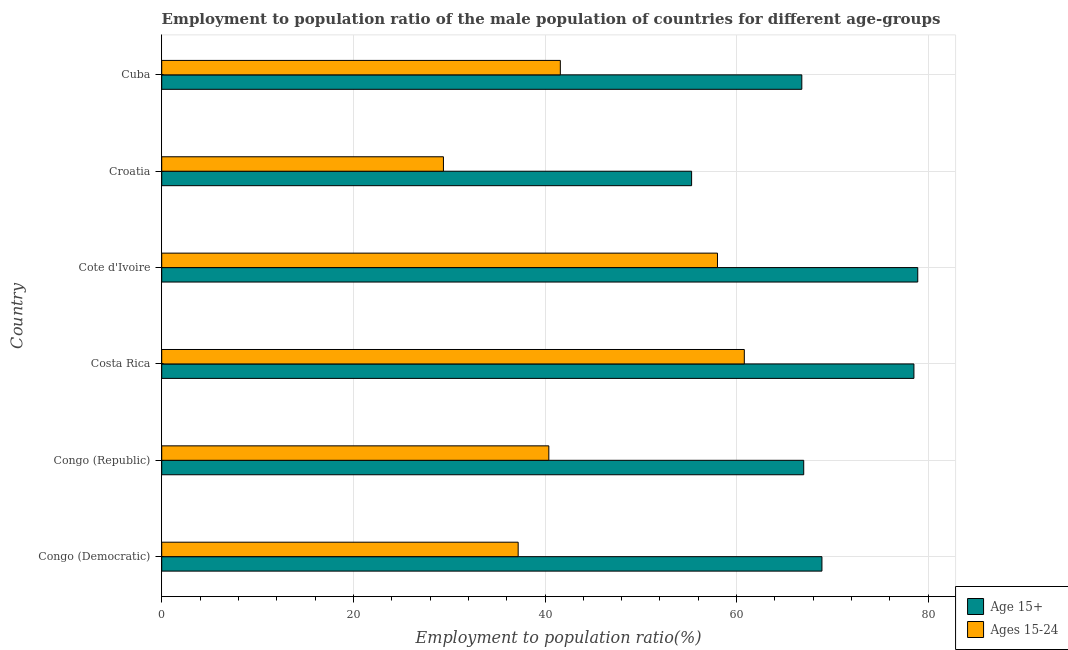How many groups of bars are there?
Give a very brief answer. 6. How many bars are there on the 4th tick from the top?
Provide a short and direct response. 2. What is the label of the 1st group of bars from the top?
Your answer should be compact. Cuba. In how many cases, is the number of bars for a given country not equal to the number of legend labels?
Provide a short and direct response. 0. What is the employment to population ratio(age 15+) in Cuba?
Offer a terse response. 66.8. Across all countries, what is the maximum employment to population ratio(age 15-24)?
Your answer should be very brief. 60.8. Across all countries, what is the minimum employment to population ratio(age 15-24)?
Offer a very short reply. 29.4. In which country was the employment to population ratio(age 15+) minimum?
Ensure brevity in your answer.  Croatia. What is the total employment to population ratio(age 15+) in the graph?
Your response must be concise. 415.4. What is the difference between the employment to population ratio(age 15-24) in Congo (Republic) and that in Cote d'Ivoire?
Offer a terse response. -17.6. What is the difference between the employment to population ratio(age 15+) in Cote d'Ivoire and the employment to population ratio(age 15-24) in Congo (Republic)?
Offer a very short reply. 38.5. What is the average employment to population ratio(age 15+) per country?
Give a very brief answer. 69.23. What is the difference between the employment to population ratio(age 15-24) and employment to population ratio(age 15+) in Costa Rica?
Provide a succinct answer. -17.7. What is the ratio of the employment to population ratio(age 15-24) in Congo (Republic) to that in Croatia?
Offer a very short reply. 1.37. What is the difference between the highest and the lowest employment to population ratio(age 15+)?
Your answer should be compact. 23.6. In how many countries, is the employment to population ratio(age 15+) greater than the average employment to population ratio(age 15+) taken over all countries?
Make the answer very short. 2. What does the 1st bar from the top in Congo (Republic) represents?
Your answer should be compact. Ages 15-24. What does the 2nd bar from the bottom in Cuba represents?
Keep it short and to the point. Ages 15-24. How many bars are there?
Make the answer very short. 12. Are all the bars in the graph horizontal?
Your answer should be compact. Yes. Does the graph contain grids?
Offer a very short reply. Yes. Where does the legend appear in the graph?
Make the answer very short. Bottom right. How are the legend labels stacked?
Provide a succinct answer. Vertical. What is the title of the graph?
Provide a succinct answer. Employment to population ratio of the male population of countries for different age-groups. Does "Under-5(female)" appear as one of the legend labels in the graph?
Make the answer very short. No. What is the label or title of the X-axis?
Your answer should be very brief. Employment to population ratio(%). What is the label or title of the Y-axis?
Ensure brevity in your answer.  Country. What is the Employment to population ratio(%) of Age 15+ in Congo (Democratic)?
Offer a terse response. 68.9. What is the Employment to population ratio(%) in Ages 15-24 in Congo (Democratic)?
Ensure brevity in your answer.  37.2. What is the Employment to population ratio(%) in Age 15+ in Congo (Republic)?
Your answer should be compact. 67. What is the Employment to population ratio(%) in Ages 15-24 in Congo (Republic)?
Provide a short and direct response. 40.4. What is the Employment to population ratio(%) of Age 15+ in Costa Rica?
Make the answer very short. 78.5. What is the Employment to population ratio(%) of Ages 15-24 in Costa Rica?
Provide a succinct answer. 60.8. What is the Employment to population ratio(%) in Age 15+ in Cote d'Ivoire?
Your response must be concise. 78.9. What is the Employment to population ratio(%) of Age 15+ in Croatia?
Your answer should be compact. 55.3. What is the Employment to population ratio(%) of Ages 15-24 in Croatia?
Give a very brief answer. 29.4. What is the Employment to population ratio(%) of Age 15+ in Cuba?
Provide a succinct answer. 66.8. What is the Employment to population ratio(%) in Ages 15-24 in Cuba?
Give a very brief answer. 41.6. Across all countries, what is the maximum Employment to population ratio(%) in Age 15+?
Provide a succinct answer. 78.9. Across all countries, what is the maximum Employment to population ratio(%) of Ages 15-24?
Keep it short and to the point. 60.8. Across all countries, what is the minimum Employment to population ratio(%) in Age 15+?
Provide a succinct answer. 55.3. Across all countries, what is the minimum Employment to population ratio(%) of Ages 15-24?
Your answer should be very brief. 29.4. What is the total Employment to population ratio(%) of Age 15+ in the graph?
Your answer should be very brief. 415.4. What is the total Employment to population ratio(%) in Ages 15-24 in the graph?
Provide a succinct answer. 267.4. What is the difference between the Employment to population ratio(%) in Age 15+ in Congo (Democratic) and that in Costa Rica?
Offer a terse response. -9.6. What is the difference between the Employment to population ratio(%) of Ages 15-24 in Congo (Democratic) and that in Costa Rica?
Keep it short and to the point. -23.6. What is the difference between the Employment to population ratio(%) in Ages 15-24 in Congo (Democratic) and that in Cote d'Ivoire?
Offer a terse response. -20.8. What is the difference between the Employment to population ratio(%) of Age 15+ in Congo (Democratic) and that in Croatia?
Your response must be concise. 13.6. What is the difference between the Employment to population ratio(%) in Age 15+ in Congo (Democratic) and that in Cuba?
Make the answer very short. 2.1. What is the difference between the Employment to population ratio(%) of Ages 15-24 in Congo (Democratic) and that in Cuba?
Make the answer very short. -4.4. What is the difference between the Employment to population ratio(%) in Age 15+ in Congo (Republic) and that in Costa Rica?
Offer a very short reply. -11.5. What is the difference between the Employment to population ratio(%) in Ages 15-24 in Congo (Republic) and that in Costa Rica?
Make the answer very short. -20.4. What is the difference between the Employment to population ratio(%) of Age 15+ in Congo (Republic) and that in Cote d'Ivoire?
Offer a terse response. -11.9. What is the difference between the Employment to population ratio(%) in Ages 15-24 in Congo (Republic) and that in Cote d'Ivoire?
Provide a succinct answer. -17.6. What is the difference between the Employment to population ratio(%) of Ages 15-24 in Congo (Republic) and that in Cuba?
Keep it short and to the point. -1.2. What is the difference between the Employment to population ratio(%) of Age 15+ in Costa Rica and that in Cote d'Ivoire?
Give a very brief answer. -0.4. What is the difference between the Employment to population ratio(%) in Ages 15-24 in Costa Rica and that in Cote d'Ivoire?
Your response must be concise. 2.8. What is the difference between the Employment to population ratio(%) of Age 15+ in Costa Rica and that in Croatia?
Your answer should be very brief. 23.2. What is the difference between the Employment to population ratio(%) of Ages 15-24 in Costa Rica and that in Croatia?
Your answer should be very brief. 31.4. What is the difference between the Employment to population ratio(%) in Age 15+ in Costa Rica and that in Cuba?
Provide a succinct answer. 11.7. What is the difference between the Employment to population ratio(%) in Ages 15-24 in Costa Rica and that in Cuba?
Provide a succinct answer. 19.2. What is the difference between the Employment to population ratio(%) of Age 15+ in Cote d'Ivoire and that in Croatia?
Provide a succinct answer. 23.6. What is the difference between the Employment to population ratio(%) of Ages 15-24 in Cote d'Ivoire and that in Croatia?
Offer a very short reply. 28.6. What is the difference between the Employment to population ratio(%) of Ages 15-24 in Croatia and that in Cuba?
Ensure brevity in your answer.  -12.2. What is the difference between the Employment to population ratio(%) in Age 15+ in Congo (Democratic) and the Employment to population ratio(%) in Ages 15-24 in Congo (Republic)?
Your answer should be compact. 28.5. What is the difference between the Employment to population ratio(%) in Age 15+ in Congo (Democratic) and the Employment to population ratio(%) in Ages 15-24 in Cote d'Ivoire?
Make the answer very short. 10.9. What is the difference between the Employment to population ratio(%) of Age 15+ in Congo (Democratic) and the Employment to population ratio(%) of Ages 15-24 in Croatia?
Provide a short and direct response. 39.5. What is the difference between the Employment to population ratio(%) of Age 15+ in Congo (Democratic) and the Employment to population ratio(%) of Ages 15-24 in Cuba?
Offer a terse response. 27.3. What is the difference between the Employment to population ratio(%) of Age 15+ in Congo (Republic) and the Employment to population ratio(%) of Ages 15-24 in Costa Rica?
Your answer should be compact. 6.2. What is the difference between the Employment to population ratio(%) of Age 15+ in Congo (Republic) and the Employment to population ratio(%) of Ages 15-24 in Croatia?
Your answer should be compact. 37.6. What is the difference between the Employment to population ratio(%) in Age 15+ in Congo (Republic) and the Employment to population ratio(%) in Ages 15-24 in Cuba?
Provide a succinct answer. 25.4. What is the difference between the Employment to population ratio(%) in Age 15+ in Costa Rica and the Employment to population ratio(%) in Ages 15-24 in Croatia?
Your answer should be very brief. 49.1. What is the difference between the Employment to population ratio(%) of Age 15+ in Costa Rica and the Employment to population ratio(%) of Ages 15-24 in Cuba?
Offer a terse response. 36.9. What is the difference between the Employment to population ratio(%) in Age 15+ in Cote d'Ivoire and the Employment to population ratio(%) in Ages 15-24 in Croatia?
Provide a short and direct response. 49.5. What is the difference between the Employment to population ratio(%) in Age 15+ in Cote d'Ivoire and the Employment to population ratio(%) in Ages 15-24 in Cuba?
Provide a succinct answer. 37.3. What is the difference between the Employment to population ratio(%) in Age 15+ in Croatia and the Employment to population ratio(%) in Ages 15-24 in Cuba?
Offer a terse response. 13.7. What is the average Employment to population ratio(%) in Age 15+ per country?
Provide a succinct answer. 69.23. What is the average Employment to population ratio(%) in Ages 15-24 per country?
Make the answer very short. 44.57. What is the difference between the Employment to population ratio(%) in Age 15+ and Employment to population ratio(%) in Ages 15-24 in Congo (Democratic)?
Give a very brief answer. 31.7. What is the difference between the Employment to population ratio(%) of Age 15+ and Employment to population ratio(%) of Ages 15-24 in Congo (Republic)?
Your response must be concise. 26.6. What is the difference between the Employment to population ratio(%) of Age 15+ and Employment to population ratio(%) of Ages 15-24 in Costa Rica?
Give a very brief answer. 17.7. What is the difference between the Employment to population ratio(%) of Age 15+ and Employment to population ratio(%) of Ages 15-24 in Cote d'Ivoire?
Offer a terse response. 20.9. What is the difference between the Employment to population ratio(%) in Age 15+ and Employment to population ratio(%) in Ages 15-24 in Croatia?
Give a very brief answer. 25.9. What is the difference between the Employment to population ratio(%) of Age 15+ and Employment to population ratio(%) of Ages 15-24 in Cuba?
Your answer should be compact. 25.2. What is the ratio of the Employment to population ratio(%) of Age 15+ in Congo (Democratic) to that in Congo (Republic)?
Offer a very short reply. 1.03. What is the ratio of the Employment to population ratio(%) of Ages 15-24 in Congo (Democratic) to that in Congo (Republic)?
Make the answer very short. 0.92. What is the ratio of the Employment to population ratio(%) of Age 15+ in Congo (Democratic) to that in Costa Rica?
Keep it short and to the point. 0.88. What is the ratio of the Employment to population ratio(%) in Ages 15-24 in Congo (Democratic) to that in Costa Rica?
Make the answer very short. 0.61. What is the ratio of the Employment to population ratio(%) in Age 15+ in Congo (Democratic) to that in Cote d'Ivoire?
Give a very brief answer. 0.87. What is the ratio of the Employment to population ratio(%) in Ages 15-24 in Congo (Democratic) to that in Cote d'Ivoire?
Your answer should be very brief. 0.64. What is the ratio of the Employment to population ratio(%) in Age 15+ in Congo (Democratic) to that in Croatia?
Your answer should be compact. 1.25. What is the ratio of the Employment to population ratio(%) in Ages 15-24 in Congo (Democratic) to that in Croatia?
Make the answer very short. 1.27. What is the ratio of the Employment to population ratio(%) in Age 15+ in Congo (Democratic) to that in Cuba?
Make the answer very short. 1.03. What is the ratio of the Employment to population ratio(%) of Ages 15-24 in Congo (Democratic) to that in Cuba?
Ensure brevity in your answer.  0.89. What is the ratio of the Employment to population ratio(%) of Age 15+ in Congo (Republic) to that in Costa Rica?
Provide a succinct answer. 0.85. What is the ratio of the Employment to population ratio(%) in Ages 15-24 in Congo (Republic) to that in Costa Rica?
Make the answer very short. 0.66. What is the ratio of the Employment to population ratio(%) of Age 15+ in Congo (Republic) to that in Cote d'Ivoire?
Your response must be concise. 0.85. What is the ratio of the Employment to population ratio(%) of Ages 15-24 in Congo (Republic) to that in Cote d'Ivoire?
Provide a succinct answer. 0.7. What is the ratio of the Employment to population ratio(%) of Age 15+ in Congo (Republic) to that in Croatia?
Offer a terse response. 1.21. What is the ratio of the Employment to population ratio(%) in Ages 15-24 in Congo (Republic) to that in Croatia?
Offer a terse response. 1.37. What is the ratio of the Employment to population ratio(%) of Ages 15-24 in Congo (Republic) to that in Cuba?
Your answer should be very brief. 0.97. What is the ratio of the Employment to population ratio(%) in Age 15+ in Costa Rica to that in Cote d'Ivoire?
Provide a succinct answer. 0.99. What is the ratio of the Employment to population ratio(%) in Ages 15-24 in Costa Rica to that in Cote d'Ivoire?
Your answer should be compact. 1.05. What is the ratio of the Employment to population ratio(%) of Age 15+ in Costa Rica to that in Croatia?
Your response must be concise. 1.42. What is the ratio of the Employment to population ratio(%) of Ages 15-24 in Costa Rica to that in Croatia?
Provide a short and direct response. 2.07. What is the ratio of the Employment to population ratio(%) of Age 15+ in Costa Rica to that in Cuba?
Make the answer very short. 1.18. What is the ratio of the Employment to population ratio(%) in Ages 15-24 in Costa Rica to that in Cuba?
Your answer should be compact. 1.46. What is the ratio of the Employment to population ratio(%) in Age 15+ in Cote d'Ivoire to that in Croatia?
Your response must be concise. 1.43. What is the ratio of the Employment to population ratio(%) in Ages 15-24 in Cote d'Ivoire to that in Croatia?
Your answer should be compact. 1.97. What is the ratio of the Employment to population ratio(%) of Age 15+ in Cote d'Ivoire to that in Cuba?
Provide a succinct answer. 1.18. What is the ratio of the Employment to population ratio(%) of Ages 15-24 in Cote d'Ivoire to that in Cuba?
Offer a terse response. 1.39. What is the ratio of the Employment to population ratio(%) of Age 15+ in Croatia to that in Cuba?
Offer a very short reply. 0.83. What is the ratio of the Employment to population ratio(%) in Ages 15-24 in Croatia to that in Cuba?
Ensure brevity in your answer.  0.71. What is the difference between the highest and the second highest Employment to population ratio(%) in Ages 15-24?
Your answer should be very brief. 2.8. What is the difference between the highest and the lowest Employment to population ratio(%) of Age 15+?
Ensure brevity in your answer.  23.6. What is the difference between the highest and the lowest Employment to population ratio(%) in Ages 15-24?
Offer a terse response. 31.4. 